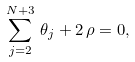<formula> <loc_0><loc_0><loc_500><loc_500>\sum _ { j = 2 } ^ { N + 3 } \, \theta _ { j } + 2 \, \rho = 0 ,</formula> 